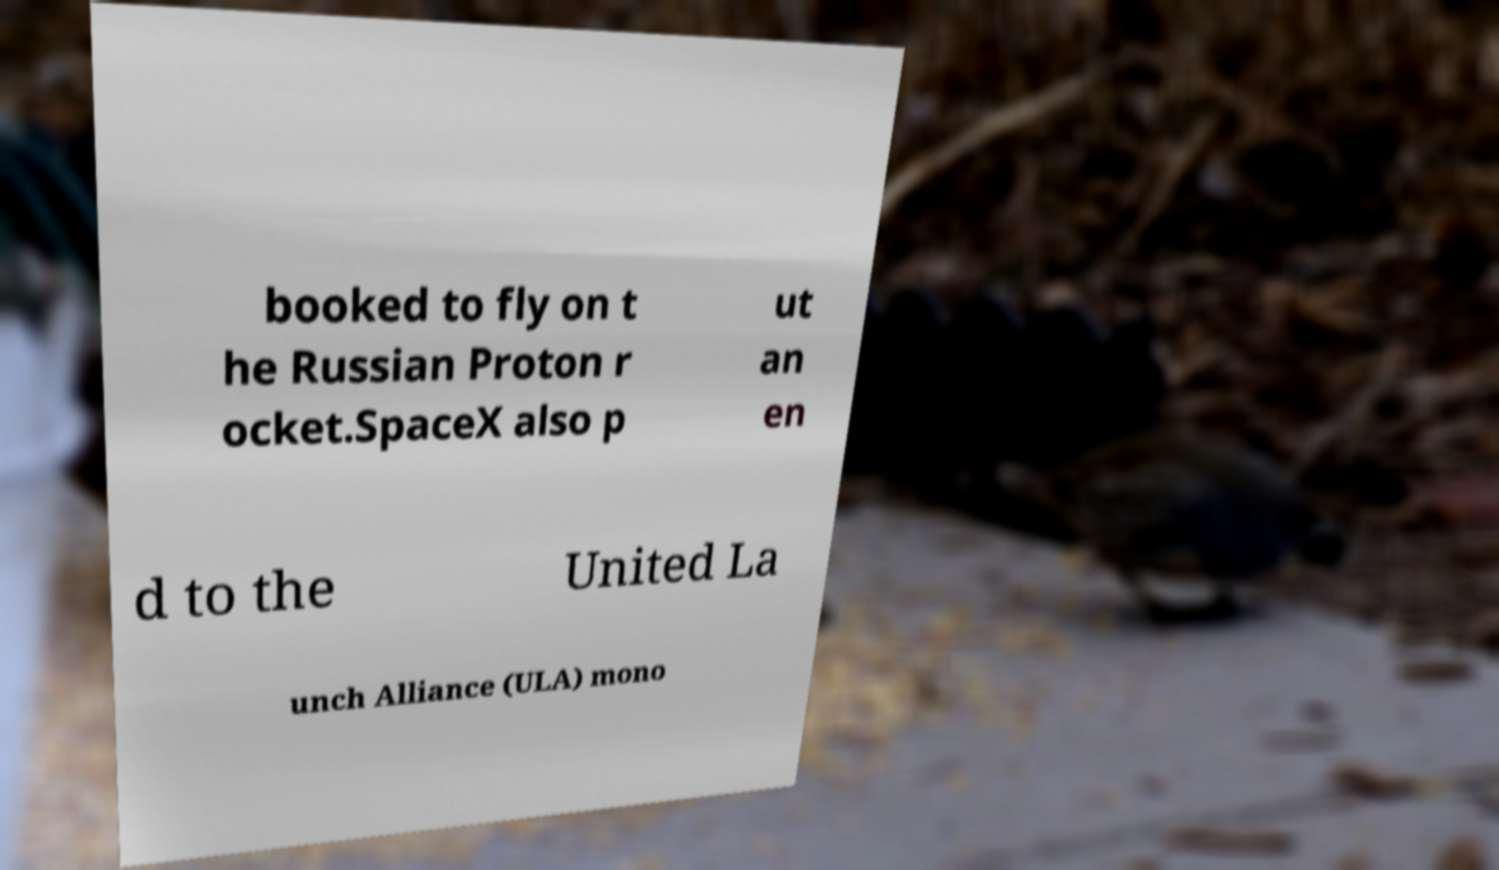I need the written content from this picture converted into text. Can you do that? booked to fly on t he Russian Proton r ocket.SpaceX also p ut an en d to the United La unch Alliance (ULA) mono 